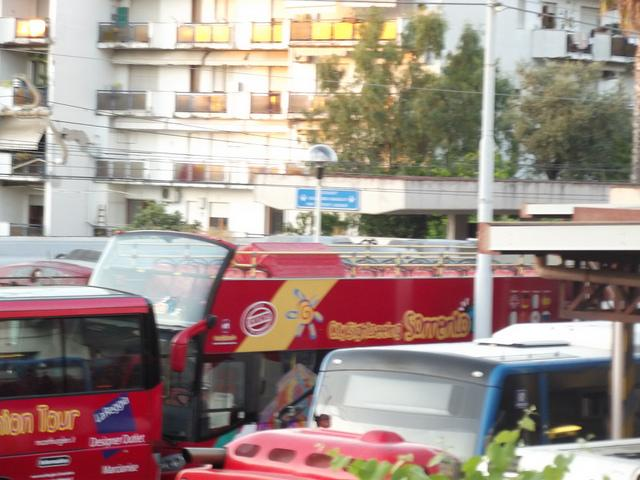What would someone be riding on top of the red bus for? Please explain your reasoning. tours. A bus has seats on the top. the bus advertises tours. 